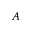<formula> <loc_0><loc_0><loc_500><loc_500>A</formula> 